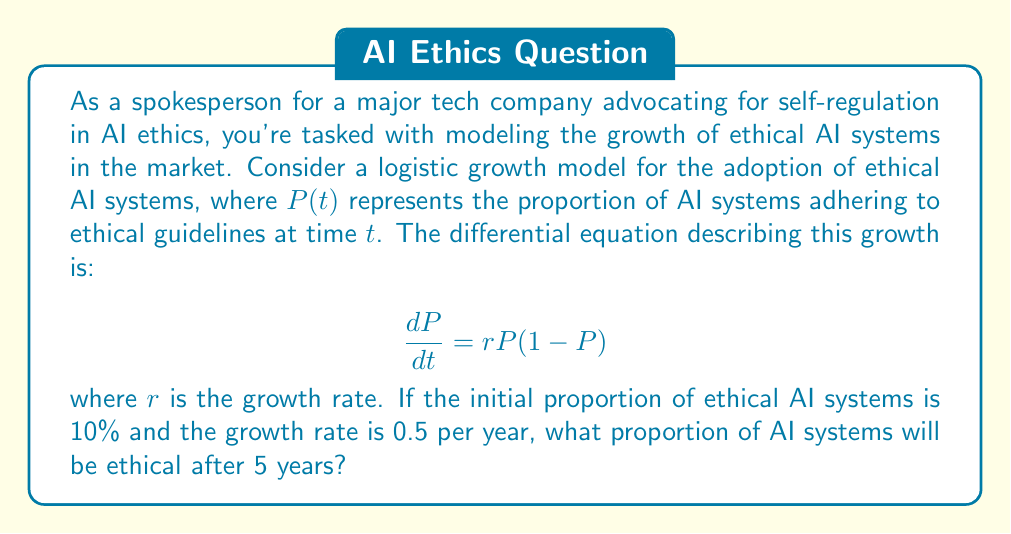Give your solution to this math problem. To solve this problem, we need to use the logistic growth model and its solution. The steps are as follows:

1) The logistic growth model is given by the differential equation:
   $$\frac{dP}{dt} = rP(1-P)$$

2) The solution to this equation is:
   $$P(t) = \frac{P_0}{P_0 + (1-P_0)e^{-rt}}$$
   where $P_0$ is the initial proportion.

3) We are given:
   $P_0 = 0.1$ (initial proportion is 10%)
   $r = 0.5$ (growth rate per year)
   $t = 5$ (we want to know the proportion after 5 years)

4) Substituting these values into the solution:
   $$P(5) = \frac{0.1}{0.1 + (1-0.1)e^{-0.5(5)}}$$

5) Simplify:
   $$P(5) = \frac{0.1}{0.1 + 0.9e^{-2.5}}$$

6) Calculate:
   $$P(5) \approx 0.7311$$

7) Convert to percentage:
   $73.11\%$

Therefore, after 5 years, approximately 73.11% of AI systems will be adhering to ethical guidelines according to this model.
Answer: 73.11% 